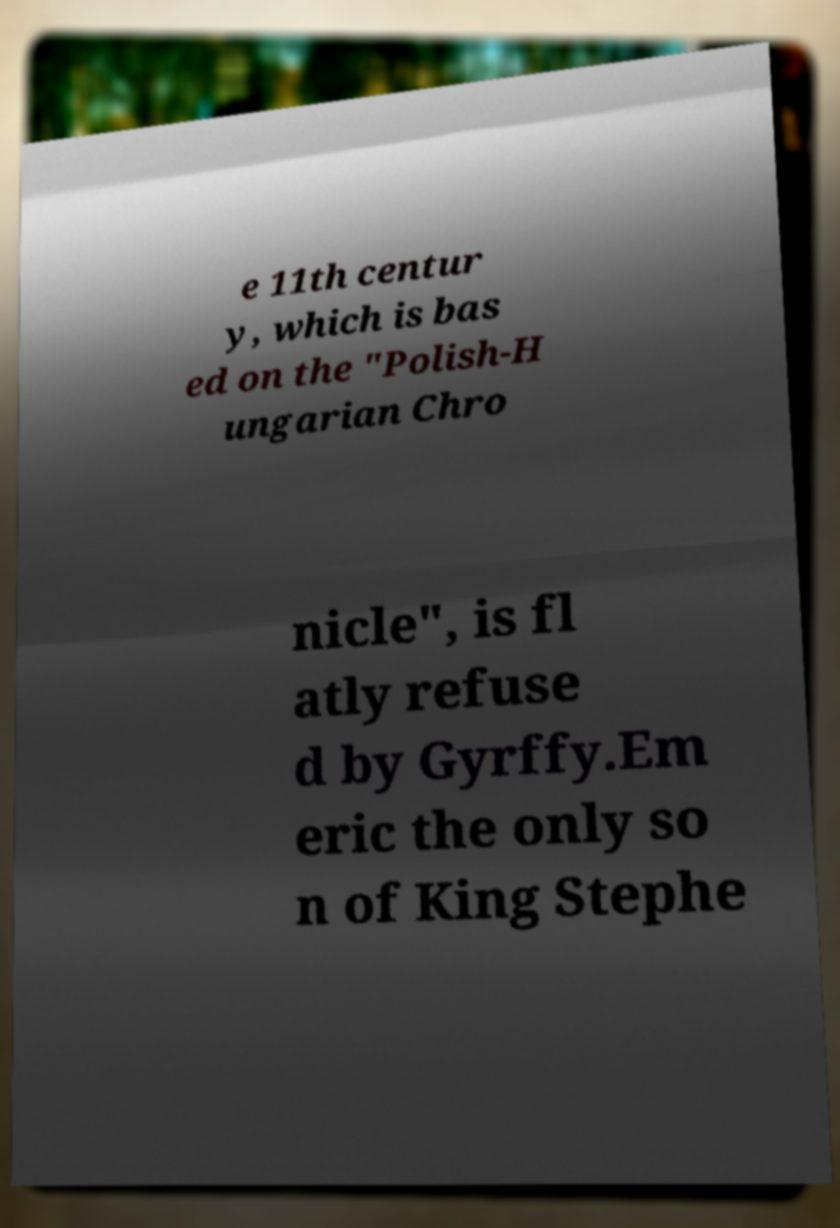Can you read and provide the text displayed in the image?This photo seems to have some interesting text. Can you extract and type it out for me? e 11th centur y, which is bas ed on the "Polish-H ungarian Chro nicle", is fl atly refuse d by Gyrffy.Em eric the only so n of King Stephe 